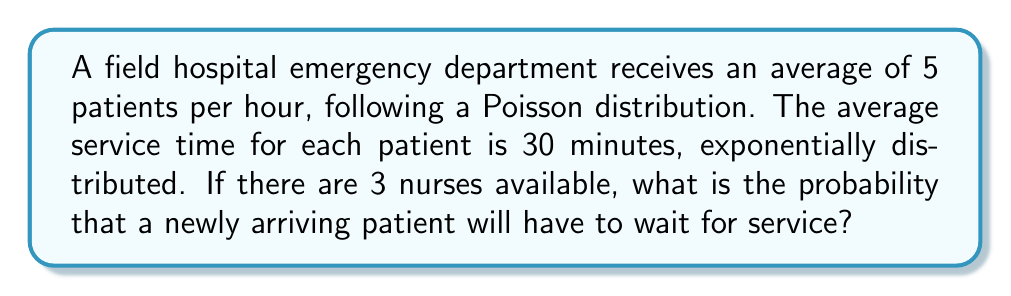Give your solution to this math problem. To solve this problem, we'll use the M/M/s queueing model, where M/M/s represents Markovian arrival/Markovian service time/s servers (nurses in this case).

Step 1: Calculate the arrival rate (λ) and service rate (μ)
λ = 5 patients/hour
μ = 1/(30/60) = 2 patients/hour/nurse

Step 2: Calculate the utilization factor (ρ)
ρ = λ/(s*μ) = 5/(3*2) = 5/6 ≈ 0.833

Step 3: Calculate the probability of zero patients in the system (P₀)
$$P_0 = \left[\sum_{n=0}^{s-1}\frac{(s\rho)^n}{n!} + \frac{(s\rho)^s}{s!(1-\rho)}\right]^{-1}$$

Substituting the values:
$$P_0 = \left[\sum_{n=0}^{2}\frac{(3*5/6)^n}{n!} + \frac{(3*5/6)^3}{3!(1-5/6)}\right]^{-1}$$
$$P_0 = \left[1 + 2.5 + \frac{(2.5)^2}{2} + \frac{(2.5)^3}{6(1/6)}\right]^{-1} \approx 0.0473$$

Step 4: Calculate the probability of waiting (P_w)
$$P_w = \frac{(s\rho)^s}{s!(1-\rho)}P_0$$

Substituting the values:
$$P_w = \frac{(3*5/6)^3}{3!(1-5/6)}*0.0473 \approx 0.5166$$

Therefore, the probability that a newly arriving patient will have to wait for service is approximately 0.5166 or 51.66%.
Answer: 0.5166 